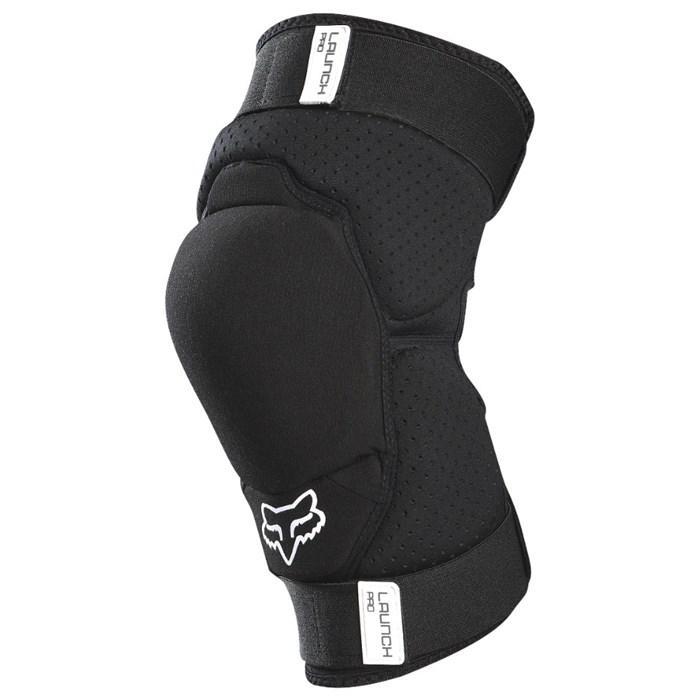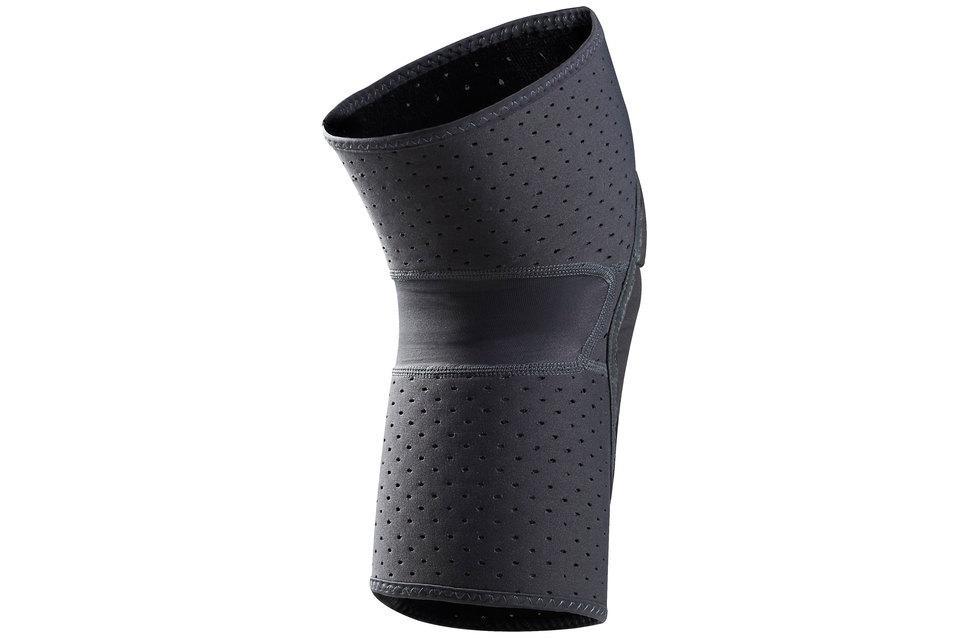The first image is the image on the left, the second image is the image on the right. Analyze the images presented: Is the assertion "The knee braces in the two images face the same direction." valid? Answer yes or no. No. 